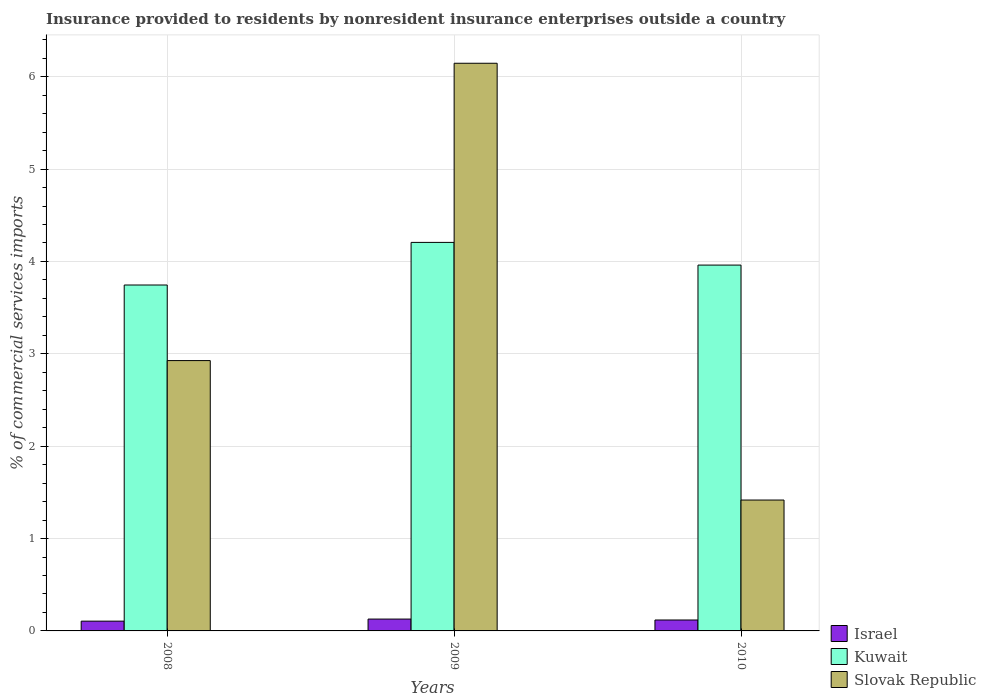How many different coloured bars are there?
Give a very brief answer. 3. How many groups of bars are there?
Your answer should be very brief. 3. Are the number of bars per tick equal to the number of legend labels?
Offer a terse response. Yes. Are the number of bars on each tick of the X-axis equal?
Give a very brief answer. Yes. How many bars are there on the 2nd tick from the right?
Provide a succinct answer. 3. What is the Insurance provided to residents in Kuwait in 2008?
Your answer should be very brief. 3.75. Across all years, what is the maximum Insurance provided to residents in Kuwait?
Make the answer very short. 4.21. Across all years, what is the minimum Insurance provided to residents in Slovak Republic?
Your response must be concise. 1.42. In which year was the Insurance provided to residents in Israel maximum?
Keep it short and to the point. 2009. What is the total Insurance provided to residents in Slovak Republic in the graph?
Give a very brief answer. 10.49. What is the difference between the Insurance provided to residents in Israel in 2009 and that in 2010?
Offer a terse response. 0.01. What is the difference between the Insurance provided to residents in Kuwait in 2008 and the Insurance provided to residents in Israel in 2009?
Make the answer very short. 3.62. What is the average Insurance provided to residents in Kuwait per year?
Give a very brief answer. 3.97. In the year 2008, what is the difference between the Insurance provided to residents in Kuwait and Insurance provided to residents in Israel?
Provide a succinct answer. 3.64. What is the ratio of the Insurance provided to residents in Kuwait in 2009 to that in 2010?
Provide a short and direct response. 1.06. Is the difference between the Insurance provided to residents in Kuwait in 2008 and 2010 greater than the difference between the Insurance provided to residents in Israel in 2008 and 2010?
Offer a very short reply. No. What is the difference between the highest and the second highest Insurance provided to residents in Slovak Republic?
Your answer should be very brief. 3.22. What is the difference between the highest and the lowest Insurance provided to residents in Slovak Republic?
Keep it short and to the point. 4.73. What does the 2nd bar from the left in 2008 represents?
Ensure brevity in your answer.  Kuwait. What does the 2nd bar from the right in 2009 represents?
Offer a very short reply. Kuwait. Are all the bars in the graph horizontal?
Offer a very short reply. No. How many years are there in the graph?
Your answer should be compact. 3. What is the difference between two consecutive major ticks on the Y-axis?
Ensure brevity in your answer.  1. Are the values on the major ticks of Y-axis written in scientific E-notation?
Keep it short and to the point. No. Does the graph contain any zero values?
Offer a very short reply. No. Does the graph contain grids?
Offer a very short reply. Yes. What is the title of the graph?
Your answer should be very brief. Insurance provided to residents by nonresident insurance enterprises outside a country. What is the label or title of the Y-axis?
Provide a succinct answer. % of commercial services imports. What is the % of commercial services imports of Israel in 2008?
Your answer should be very brief. 0.11. What is the % of commercial services imports of Kuwait in 2008?
Keep it short and to the point. 3.75. What is the % of commercial services imports in Slovak Republic in 2008?
Your response must be concise. 2.93. What is the % of commercial services imports in Israel in 2009?
Ensure brevity in your answer.  0.13. What is the % of commercial services imports in Kuwait in 2009?
Your answer should be compact. 4.21. What is the % of commercial services imports of Slovak Republic in 2009?
Provide a short and direct response. 6.15. What is the % of commercial services imports in Israel in 2010?
Your response must be concise. 0.12. What is the % of commercial services imports in Kuwait in 2010?
Provide a succinct answer. 3.96. What is the % of commercial services imports in Slovak Republic in 2010?
Keep it short and to the point. 1.42. Across all years, what is the maximum % of commercial services imports in Israel?
Keep it short and to the point. 0.13. Across all years, what is the maximum % of commercial services imports in Kuwait?
Provide a short and direct response. 4.21. Across all years, what is the maximum % of commercial services imports in Slovak Republic?
Make the answer very short. 6.15. Across all years, what is the minimum % of commercial services imports in Israel?
Your response must be concise. 0.11. Across all years, what is the minimum % of commercial services imports of Kuwait?
Offer a terse response. 3.75. Across all years, what is the minimum % of commercial services imports of Slovak Republic?
Make the answer very short. 1.42. What is the total % of commercial services imports of Israel in the graph?
Your answer should be compact. 0.35. What is the total % of commercial services imports in Kuwait in the graph?
Give a very brief answer. 11.91. What is the total % of commercial services imports of Slovak Republic in the graph?
Make the answer very short. 10.49. What is the difference between the % of commercial services imports in Israel in 2008 and that in 2009?
Ensure brevity in your answer.  -0.02. What is the difference between the % of commercial services imports in Kuwait in 2008 and that in 2009?
Your answer should be very brief. -0.46. What is the difference between the % of commercial services imports in Slovak Republic in 2008 and that in 2009?
Offer a terse response. -3.22. What is the difference between the % of commercial services imports of Israel in 2008 and that in 2010?
Offer a terse response. -0.01. What is the difference between the % of commercial services imports of Kuwait in 2008 and that in 2010?
Provide a succinct answer. -0.22. What is the difference between the % of commercial services imports in Slovak Republic in 2008 and that in 2010?
Offer a terse response. 1.51. What is the difference between the % of commercial services imports of Kuwait in 2009 and that in 2010?
Your answer should be very brief. 0.25. What is the difference between the % of commercial services imports of Slovak Republic in 2009 and that in 2010?
Offer a very short reply. 4.73. What is the difference between the % of commercial services imports in Israel in 2008 and the % of commercial services imports in Kuwait in 2009?
Your answer should be compact. -4.1. What is the difference between the % of commercial services imports in Israel in 2008 and the % of commercial services imports in Slovak Republic in 2009?
Your answer should be compact. -6.04. What is the difference between the % of commercial services imports of Kuwait in 2008 and the % of commercial services imports of Slovak Republic in 2009?
Offer a terse response. -2.4. What is the difference between the % of commercial services imports in Israel in 2008 and the % of commercial services imports in Kuwait in 2010?
Offer a very short reply. -3.85. What is the difference between the % of commercial services imports of Israel in 2008 and the % of commercial services imports of Slovak Republic in 2010?
Your answer should be compact. -1.31. What is the difference between the % of commercial services imports of Kuwait in 2008 and the % of commercial services imports of Slovak Republic in 2010?
Ensure brevity in your answer.  2.33. What is the difference between the % of commercial services imports in Israel in 2009 and the % of commercial services imports in Kuwait in 2010?
Keep it short and to the point. -3.83. What is the difference between the % of commercial services imports of Israel in 2009 and the % of commercial services imports of Slovak Republic in 2010?
Your answer should be very brief. -1.29. What is the difference between the % of commercial services imports in Kuwait in 2009 and the % of commercial services imports in Slovak Republic in 2010?
Provide a succinct answer. 2.79. What is the average % of commercial services imports in Israel per year?
Your answer should be very brief. 0.12. What is the average % of commercial services imports in Kuwait per year?
Provide a short and direct response. 3.97. What is the average % of commercial services imports in Slovak Republic per year?
Provide a short and direct response. 3.5. In the year 2008, what is the difference between the % of commercial services imports of Israel and % of commercial services imports of Kuwait?
Offer a very short reply. -3.64. In the year 2008, what is the difference between the % of commercial services imports of Israel and % of commercial services imports of Slovak Republic?
Keep it short and to the point. -2.82. In the year 2008, what is the difference between the % of commercial services imports in Kuwait and % of commercial services imports in Slovak Republic?
Provide a short and direct response. 0.82. In the year 2009, what is the difference between the % of commercial services imports of Israel and % of commercial services imports of Kuwait?
Offer a terse response. -4.08. In the year 2009, what is the difference between the % of commercial services imports in Israel and % of commercial services imports in Slovak Republic?
Your response must be concise. -6.02. In the year 2009, what is the difference between the % of commercial services imports of Kuwait and % of commercial services imports of Slovak Republic?
Give a very brief answer. -1.94. In the year 2010, what is the difference between the % of commercial services imports of Israel and % of commercial services imports of Kuwait?
Provide a succinct answer. -3.84. In the year 2010, what is the difference between the % of commercial services imports in Israel and % of commercial services imports in Slovak Republic?
Your answer should be very brief. -1.3. In the year 2010, what is the difference between the % of commercial services imports of Kuwait and % of commercial services imports of Slovak Republic?
Keep it short and to the point. 2.54. What is the ratio of the % of commercial services imports of Israel in 2008 to that in 2009?
Your answer should be compact. 0.83. What is the ratio of the % of commercial services imports in Kuwait in 2008 to that in 2009?
Your response must be concise. 0.89. What is the ratio of the % of commercial services imports of Slovak Republic in 2008 to that in 2009?
Your answer should be compact. 0.48. What is the ratio of the % of commercial services imports in Israel in 2008 to that in 2010?
Your answer should be compact. 0.9. What is the ratio of the % of commercial services imports of Kuwait in 2008 to that in 2010?
Provide a short and direct response. 0.95. What is the ratio of the % of commercial services imports of Slovak Republic in 2008 to that in 2010?
Offer a terse response. 2.07. What is the ratio of the % of commercial services imports of Israel in 2009 to that in 2010?
Your answer should be very brief. 1.08. What is the ratio of the % of commercial services imports of Kuwait in 2009 to that in 2010?
Your answer should be compact. 1.06. What is the ratio of the % of commercial services imports of Slovak Republic in 2009 to that in 2010?
Your answer should be compact. 4.34. What is the difference between the highest and the second highest % of commercial services imports in Kuwait?
Offer a terse response. 0.25. What is the difference between the highest and the second highest % of commercial services imports of Slovak Republic?
Make the answer very short. 3.22. What is the difference between the highest and the lowest % of commercial services imports in Israel?
Offer a very short reply. 0.02. What is the difference between the highest and the lowest % of commercial services imports in Kuwait?
Give a very brief answer. 0.46. What is the difference between the highest and the lowest % of commercial services imports of Slovak Republic?
Give a very brief answer. 4.73. 